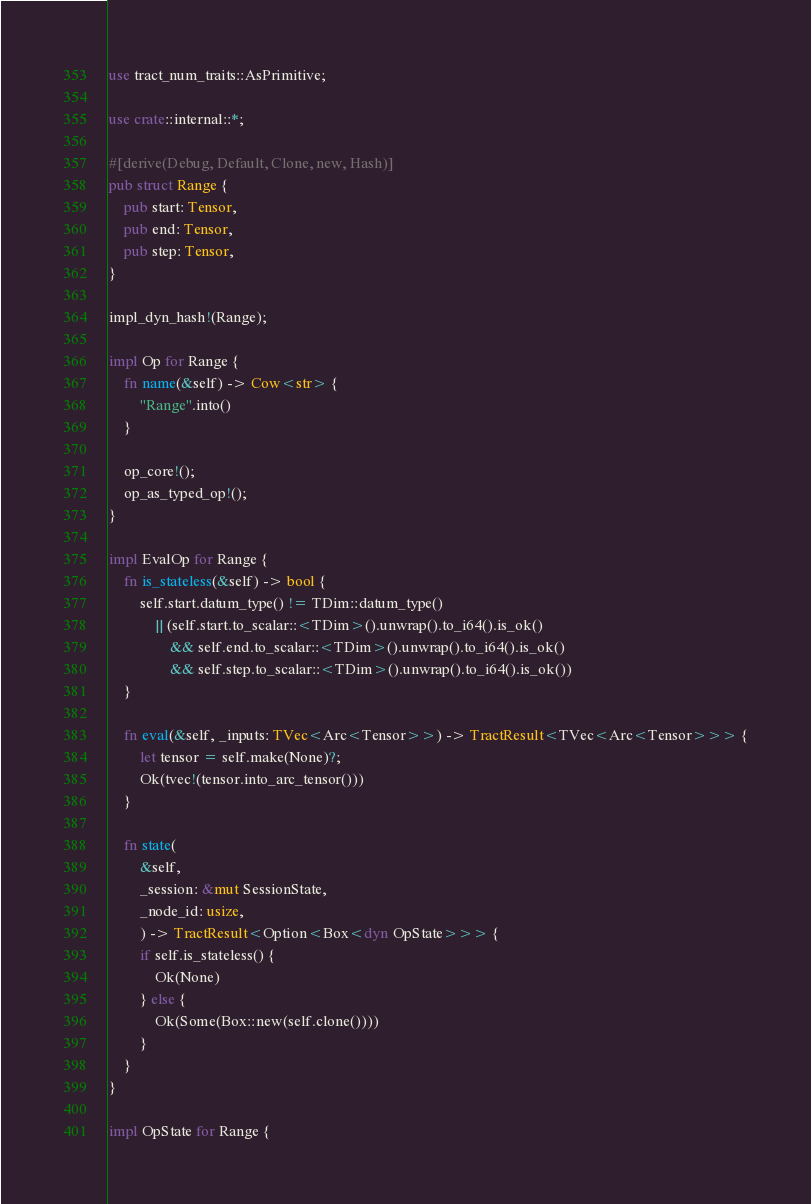Convert code to text. <code><loc_0><loc_0><loc_500><loc_500><_Rust_>use tract_num_traits::AsPrimitive;

use crate::internal::*;

#[derive(Debug, Default, Clone, new, Hash)]
pub struct Range {
    pub start: Tensor,
    pub end: Tensor,
    pub step: Tensor,
}

impl_dyn_hash!(Range);

impl Op for Range {
    fn name(&self) -> Cow<str> {
        "Range".into()
    }

    op_core!();
    op_as_typed_op!();
}

impl EvalOp for Range {
    fn is_stateless(&self) -> bool {
        self.start.datum_type() != TDim::datum_type()
            || (self.start.to_scalar::<TDim>().unwrap().to_i64().is_ok()
                && self.end.to_scalar::<TDim>().unwrap().to_i64().is_ok()
                && self.step.to_scalar::<TDim>().unwrap().to_i64().is_ok())
    }

    fn eval(&self, _inputs: TVec<Arc<Tensor>>) -> TractResult<TVec<Arc<Tensor>>> {
        let tensor = self.make(None)?;
        Ok(tvec!(tensor.into_arc_tensor()))
    }

    fn state(
        &self,
        _session: &mut SessionState,
        _node_id: usize,
        ) -> TractResult<Option<Box<dyn OpState>>> {
        if self.is_stateless() {
            Ok(None)
        } else {
            Ok(Some(Box::new(self.clone())))
        }
    }
}

impl OpState for Range {</code> 